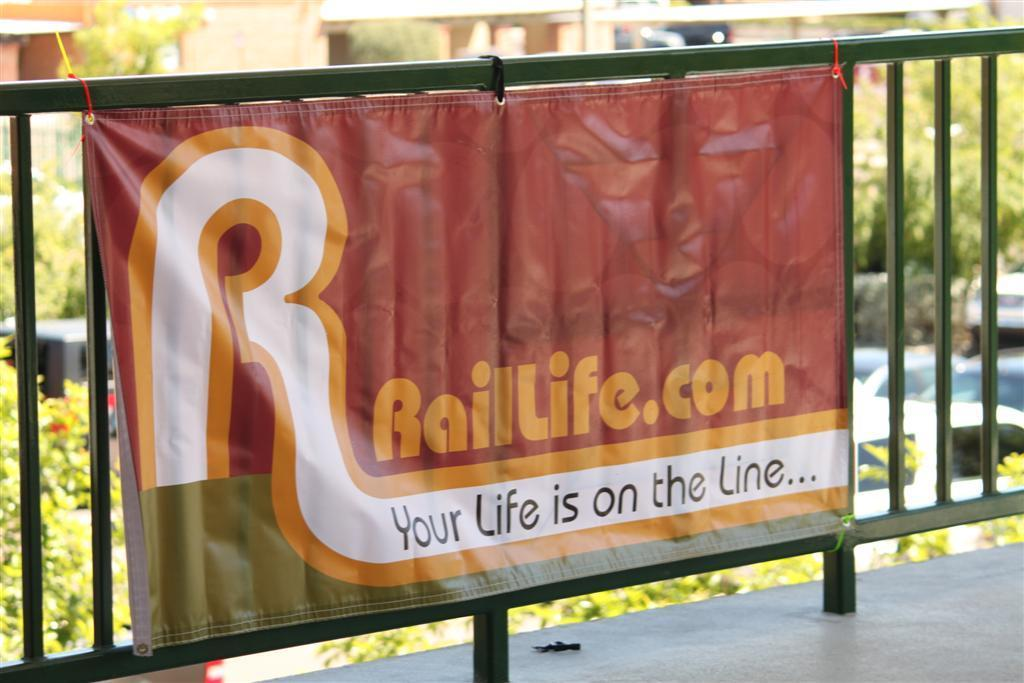<image>
Present a compact description of the photo's key features. A red sign with mostly orange and white text, advertises for RailLife.com. 